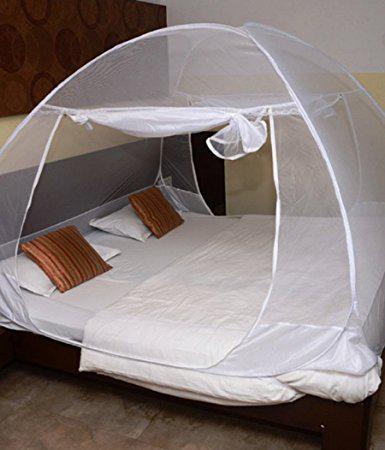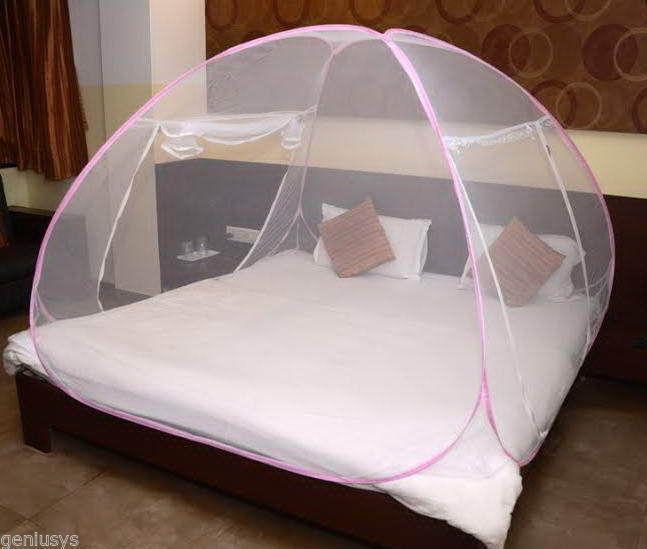The first image is the image on the left, the second image is the image on the right. Evaluate the accuracy of this statement regarding the images: "Each image shows a bed with a rounded dome-shaped canopy with non-dark trim over its mattress, and one bed is positioned at a leftward angle.". Is it true? Answer yes or no. Yes. The first image is the image on the left, the second image is the image on the right. For the images displayed, is the sentence "In each image, an igloo-shaped net cover is positioned over a double bed with brown and white pillows." factually correct? Answer yes or no. Yes. 